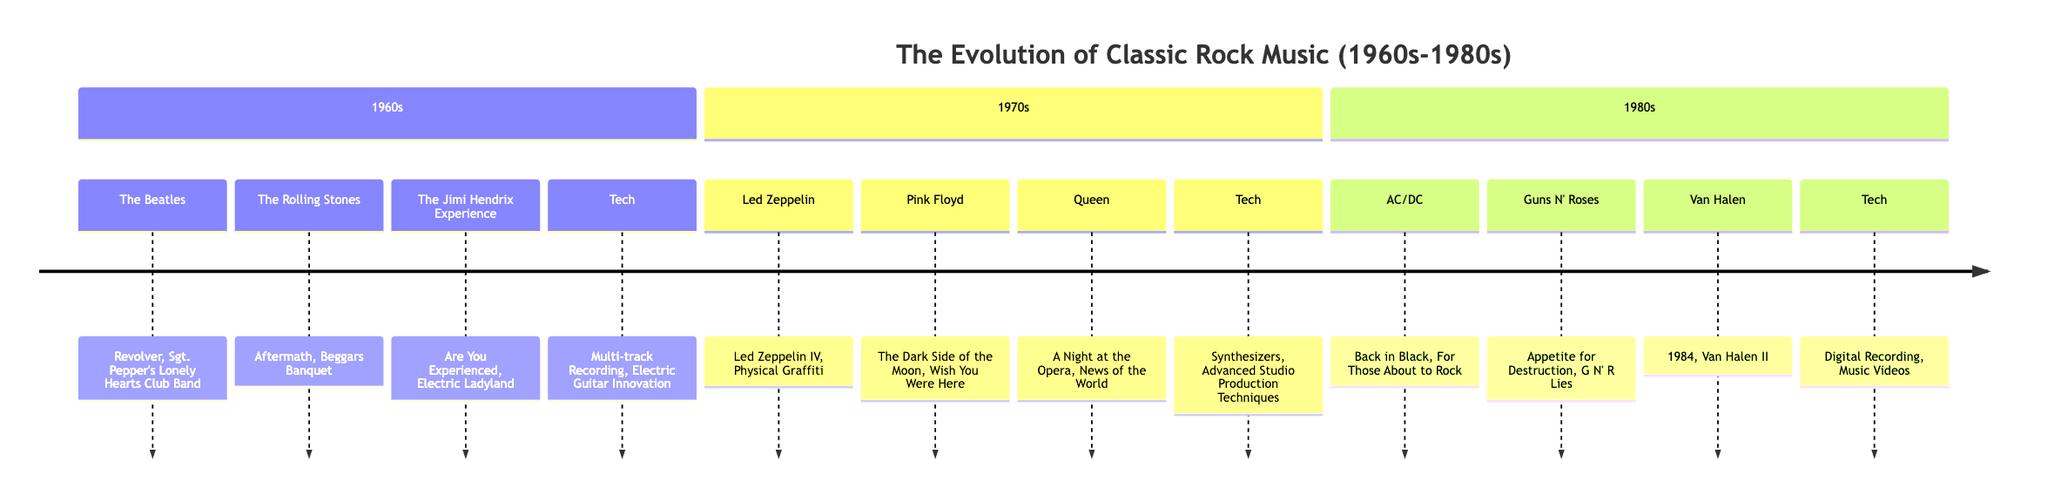What major technological advancement was introduced in the 1960s? The diagram lists "Multi-track Recording" and "Electric Guitar Innovation" as the key technological advancements from the 1960s section, highlighting "Multi-track Recording" as a significant advancement for that time.
Answer: Multi-track Recording Which band released the album "Back in Black"? The section for the 1980s specifically lists "AC/DC" alongside their significant albums, one of which is "Back in Black."
Answer: AC/DC How many bands are represented in the 1970s section? By counting the entries listed in the 1970s section of the diagram, we see there are four bands specified: Led Zeppelin, Pink Floyd, Queen, and the band members mentioned.
Answer: 4 What album did Pink Floyd release in the 1970s? The diagram states that Pink Floyd released two significant albums during the 1970s, which are "The Dark Side of the Moon" and "Wish You Were Here." Therefore, we can identify either as the answer.
Answer: The Dark Side of the Moon Which two bands are associated with the 1980s? The 1980s section lists three bands: AC/DC, Guns N' Roses, and Van Halen, but the question pertains to just two. The answer can be any two names from the provided list.
Answer: AC/DC, Guns N' Roses What is the technological advancement introduced in the 1970s? In the 1970s section of the diagram, it lists "Synthesizers" and "Advanced Studio Production Techniques" as the technological advancements; either of these can serve as the answer.
Answer: Synthesizers What is one key album from The Beatles listed in the 1960s? The 1960s section lists two key albums from The Beatles: "Revolver" and "Sgt. Pepper's Lonely Hearts Club Band." Either can be a valid response.
Answer: Revolver Which section of the diagram features Queen? To find where Queen fits in the diagram, we can look at the band listings; they are placed under the 1970s section.
Answer: 1970s Which band is associated with the album "Appetite for Destruction"? The diagram lists "Guns N' Roses" alongside their key albums, one of which is "Appetite for Destruction."
Answer: Guns N' Roses 